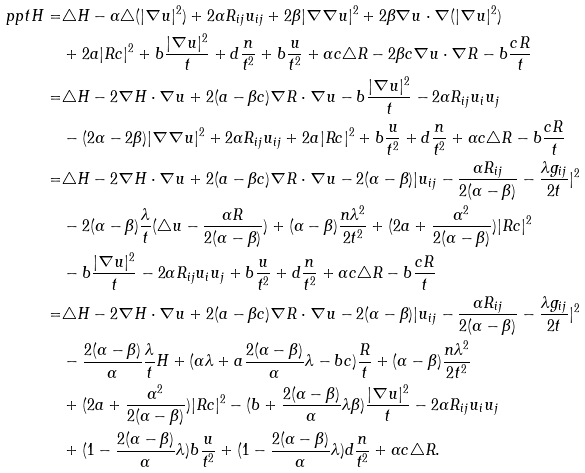Convert formula to latex. <formula><loc_0><loc_0><loc_500><loc_500>\ p p t H = & \triangle H - \alpha \triangle ( | \nabla u | ^ { 2 } ) + 2 \alpha R _ { i j } u _ { i j } + 2 \beta | \nabla \nabla u | ^ { 2 } + 2 \beta \nabla u \cdot \nabla ( | \nabla u | ^ { 2 } ) \\ & + 2 a | R c | ^ { 2 } + b \frac { | \nabla u | ^ { 2 } } { t } + d \frac { n } { t ^ { 2 } } + b \frac { u } { t ^ { 2 } } + \alpha c \triangle R - 2 \beta c \nabla u \cdot \nabla R - b \frac { c R } { t } \\ = & \triangle H - 2 \nabla H \cdot \nabla u + 2 ( a - \beta c ) \nabla R \cdot \nabla u - b \frac { | \nabla u | ^ { 2 } } { t } - 2 \alpha R _ { i j } u _ { i } u _ { j } \\ & - ( 2 \alpha - 2 \beta ) | \nabla \nabla u | ^ { 2 } + 2 \alpha R _ { i j } u _ { i j } + 2 a | R c | ^ { 2 } + b \frac { u } { t ^ { 2 } } + d \frac { n } { t ^ { 2 } } + \alpha c \triangle R - b \frac { c R } { t } \\ = & \triangle H - 2 \nabla H \cdot \nabla u + 2 ( a - \beta c ) \nabla R \cdot \nabla u - 2 ( \alpha - \beta ) | u _ { i j } - \frac { \alpha R _ { i j } } { 2 ( \alpha - \beta ) } - \frac { \lambda g _ { i j } } { 2 t } | ^ { 2 } \\ & - 2 ( \alpha - \beta ) \frac { \lambda } { t } ( \triangle u - \frac { \alpha R } { 2 ( \alpha - \beta ) } ) + ( \alpha - \beta ) \frac { n \lambda ^ { 2 } } { 2 t ^ { 2 } } + ( 2 a + \frac { \alpha ^ { 2 } } { 2 ( \alpha - \beta ) } ) | R c | ^ { 2 } \\ & - b \frac { | \nabla u | ^ { 2 } } { t } - 2 \alpha R _ { i j } u _ { i } u _ { j } + b \frac { u } { t ^ { 2 } } + d \frac { n } { t ^ { 2 } } + \alpha c \triangle R - b \frac { c R } { t } \\ = & \triangle H - 2 \nabla H \cdot \nabla u + 2 ( a - \beta c ) \nabla R \cdot \nabla u - 2 ( \alpha - \beta ) | u _ { i j } - \frac { \alpha R _ { i j } } { 2 ( \alpha - \beta ) } - \frac { \lambda g _ { i j } } { 2 t } | ^ { 2 } \\ & - \frac { 2 ( \alpha - \beta ) } { \alpha } \frac { \lambda } { t } H + ( \alpha \lambda + a \frac { 2 ( \alpha - \beta ) } { \alpha } \lambda - b c ) \frac { R } { t } + ( \alpha - \beta ) \frac { n \lambda ^ { 2 } } { 2 t ^ { 2 } } \\ & + ( 2 a + \frac { \alpha ^ { 2 } } { 2 ( \alpha - \beta ) } ) | R c | ^ { 2 } - ( b + \frac { 2 ( \alpha - \beta ) } { \alpha } \lambda \beta ) \frac { | \nabla u | ^ { 2 } } { t } - 2 \alpha R _ { i j } u _ { i } u _ { j } \\ & + ( 1 - \frac { 2 ( \alpha - \beta ) } { \alpha } \lambda ) b \frac { u } { t ^ { 2 } } + ( 1 - \frac { 2 ( \alpha - \beta ) } { \alpha } \lambda ) d \frac { n } { t ^ { 2 } } + \alpha c \triangle R .</formula> 